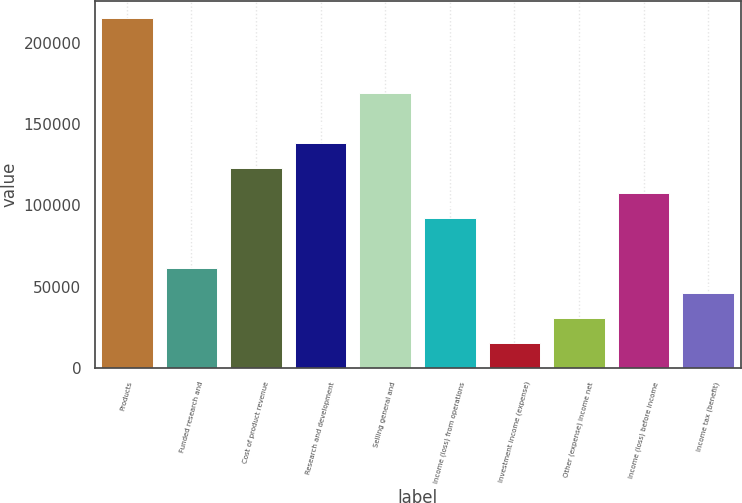Convert chart. <chart><loc_0><loc_0><loc_500><loc_500><bar_chart><fcel>Products<fcel>Funded research and<fcel>Cost of product revenue<fcel>Research and development<fcel>Selling general and<fcel>Income (loss) from operations<fcel>Investment income (expense)<fcel>Other (expense) income net<fcel>Income (loss) before income<fcel>Income tax (benefit)<nl><fcel>215475<fcel>61564.4<fcel>123129<fcel>138520<fcel>169302<fcel>92346.6<fcel>15391.1<fcel>30782.2<fcel>107738<fcel>46173.3<nl></chart> 